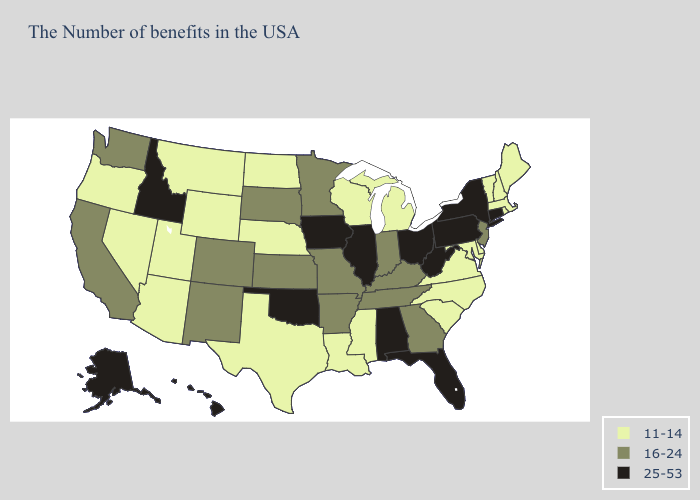What is the lowest value in states that border Iowa?
Write a very short answer. 11-14. What is the highest value in the South ?
Answer briefly. 25-53. What is the value of Indiana?
Quick response, please. 16-24. What is the lowest value in the West?
Concise answer only. 11-14. What is the value of Maine?
Keep it brief. 11-14. Name the states that have a value in the range 11-14?
Concise answer only. Maine, Massachusetts, Rhode Island, New Hampshire, Vermont, Delaware, Maryland, Virginia, North Carolina, South Carolina, Michigan, Wisconsin, Mississippi, Louisiana, Nebraska, Texas, North Dakota, Wyoming, Utah, Montana, Arizona, Nevada, Oregon. Does South Dakota have the same value as Georgia?
Be succinct. Yes. Name the states that have a value in the range 11-14?
Write a very short answer. Maine, Massachusetts, Rhode Island, New Hampshire, Vermont, Delaware, Maryland, Virginia, North Carolina, South Carolina, Michigan, Wisconsin, Mississippi, Louisiana, Nebraska, Texas, North Dakota, Wyoming, Utah, Montana, Arizona, Nevada, Oregon. What is the lowest value in states that border Maine?
Keep it brief. 11-14. What is the lowest value in the West?
Short answer required. 11-14. What is the lowest value in states that border Colorado?
Quick response, please. 11-14. Does Iowa have the lowest value in the MidWest?
Quick response, please. No. What is the value of Vermont?
Keep it brief. 11-14. What is the value of Montana?
Short answer required. 11-14. How many symbols are there in the legend?
Concise answer only. 3. 